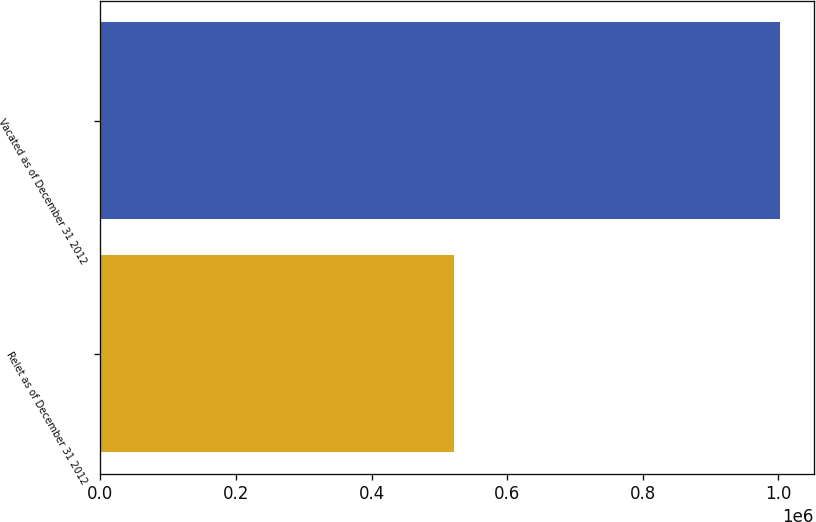Convert chart. <chart><loc_0><loc_0><loc_500><loc_500><bar_chart><fcel>Relet as of December 31 2012<fcel>Vacated as of December 31 2012<nl><fcel>521000<fcel>1.002e+06<nl></chart> 